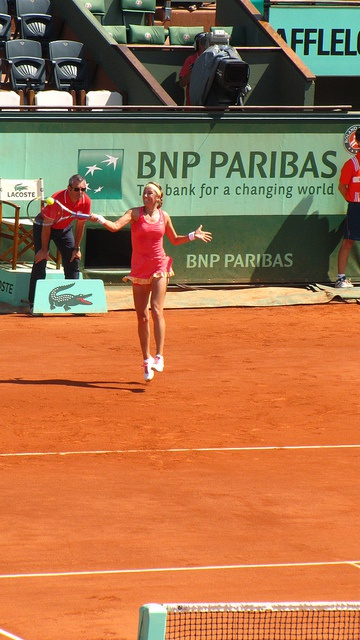Describe the objects in this image and their specific colors. I can see people in gray, brown, tan, and salmon tones, people in gray, black, brown, and maroon tones, chair in gray, ivory, maroon, darkgray, and lightgreen tones, chair in gray, black, darkgray, and blue tones, and people in gray, black, brown, and maroon tones in this image. 